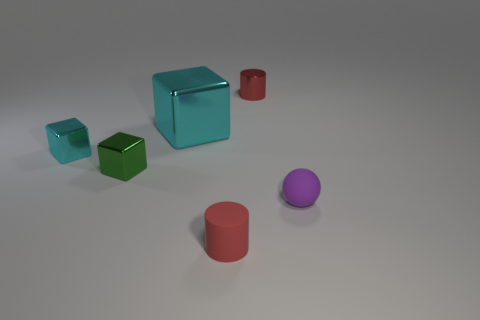There is a object that is behind the big metallic cube; is it the same shape as the cyan shiny thing in front of the large shiny block?
Keep it short and to the point. No. What number of other objects are there of the same material as the big cube?
Give a very brief answer. 3. Is the small cylinder in front of the small purple object made of the same material as the small red cylinder that is right of the rubber cylinder?
Your answer should be compact. No. What is the shape of the big object that is made of the same material as the tiny cyan thing?
Your answer should be very brief. Cube. Is there any other thing that is the same color as the large shiny block?
Keep it short and to the point. Yes. What number of small cylinders are there?
Keep it short and to the point. 2. The small object that is both behind the small green object and to the right of the small cyan block has what shape?
Ensure brevity in your answer.  Cylinder. What is the shape of the matte object on the left side of the tiny red cylinder that is behind the cyan object that is in front of the big thing?
Your answer should be very brief. Cylinder. What is the material of the small object that is behind the purple matte thing and on the right side of the small red matte cylinder?
Your response must be concise. Metal. What number of rubber balls have the same size as the matte cylinder?
Give a very brief answer. 1. 